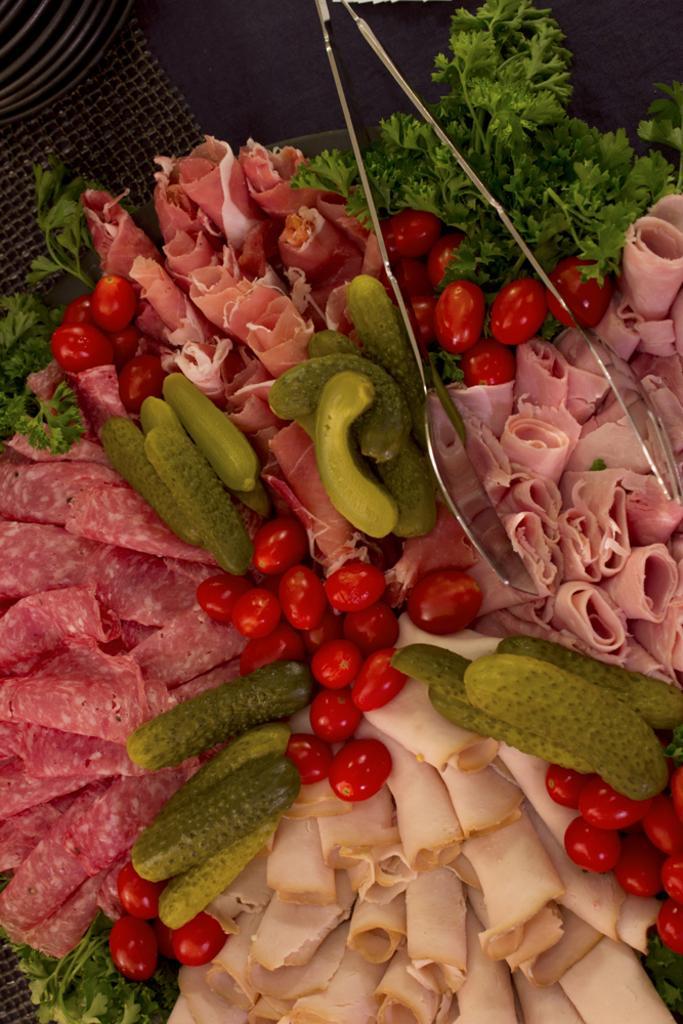Please provide a concise description of this image. In this image there is a plate, in that place there are food items and tongs. 